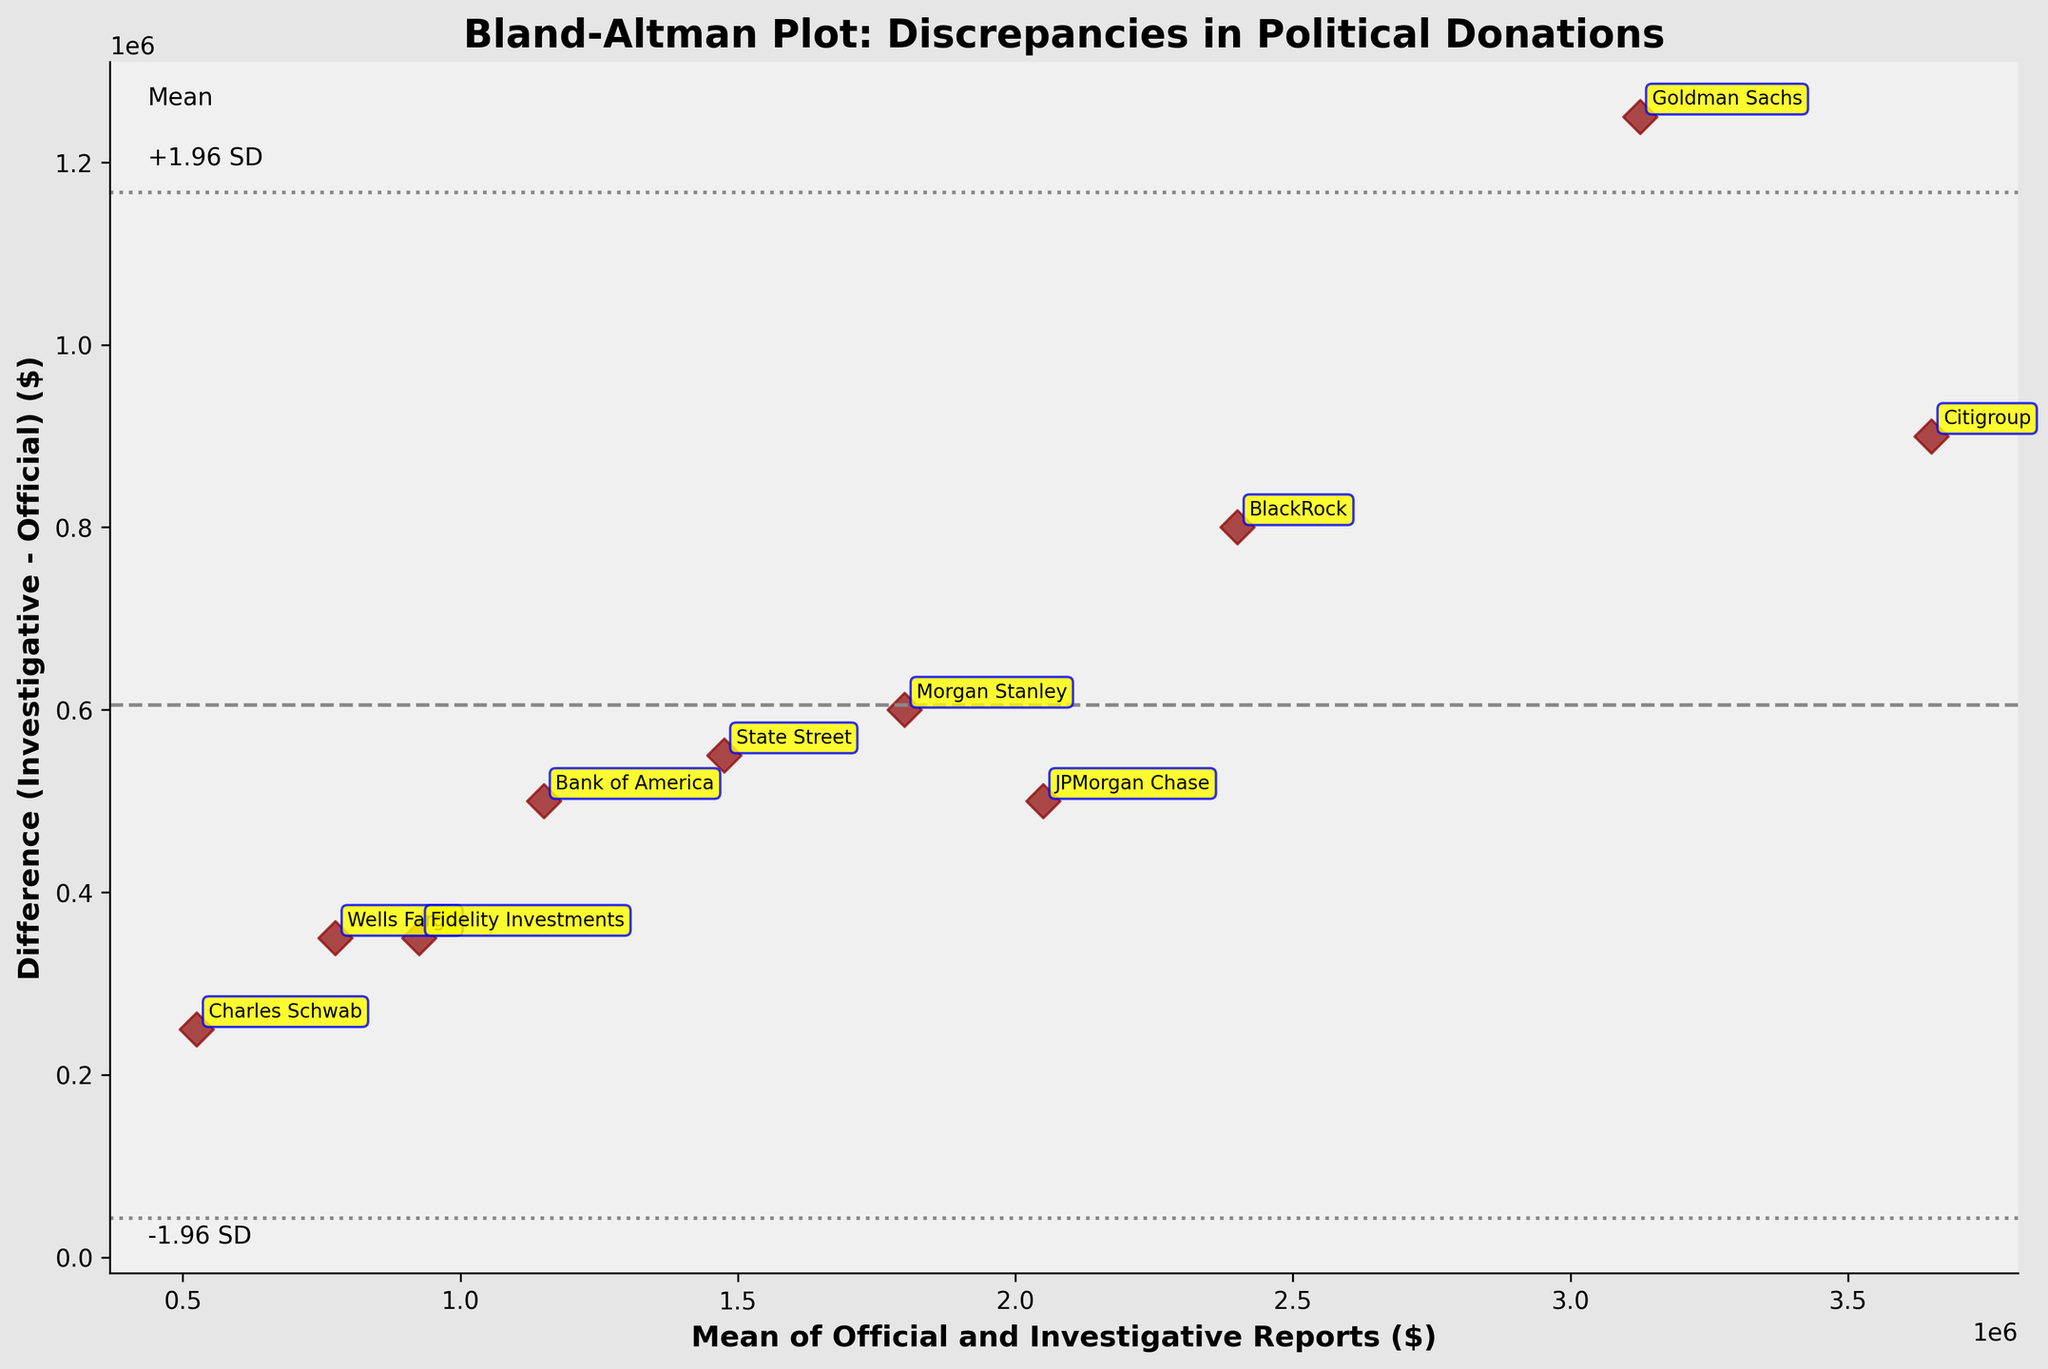What is the title of the plot? The plot's title is shown at the top of the figure and reads "Bland-Altman Plot: Discrepancies in Political Donations".
Answer: Bland-Altman Plot: Discrepancies in Political Donations Which firm shows the largest discrepancy between investigative and official reports? The largest discrepancy is indicated by the highest data point on the y-axis. Goldman Sachs has the highest difference (1,250,000).
Answer: Goldman Sachs What do the dashed horizontal lines represent? The dashed line at the center represents the mean difference, while the upper and lower dashed lines represent the mean difference ±1.96 times the standard deviation of the differences.
Answer: Mean difference, ±1.96 SD Which firm has the smallest (closest to zero) discrepancy between investigative and official reports? The firm with the smallest y-value (difference) is the one closest to zero. Charles Schwab shows the smallest difference (250,000).
Answer: Charles Schwab What is the color and shape used for the data points? The data points in the plot are represented as diamond-shaped ('D') markers and are colored dark red.
Answer: Dark red diamonds What is the mean of the documented and investigative donations for State Street? You can find State Street's mean on the x-axis where its corresponding label is situated. The mean value for State Street is (1,200,000 + 1,750,000) / 2 = 1,475,000.
Answer: 1,475,000 Which firm is represented by the data point with a mean donation value of 2,500,000? The firm with the mean donation value of 2,500,000 is located by finding the point on the x-axis closest to this value. JPMorgan Chase corresponds to this mean value ( (1,800,000 + 2,300,000) / 2 = 2,050,000 ).
Answer: JPMorgan Chase What is the average difference between investigative and official reports across all firms? Calculate the mean of the differences for all firms listed. Sum: 1250000 + 500000 + 900000 + 600000 + 500000 + 350000 + 800000 + 550000 + 350000 + 250000 = 6,550,000. Mean: 6,550,000 / 10 = 655,000.
Answer: 655,000 How many firms fall outside the limits of agreement (mean ±1.96 SD)? By visually inspecting the plot, observe data points that fall above or below the dashed lines. No firm exceeds the upper or lower limits on the plot.
Answer: None Which firm has a mean donation value closest to 3,150,000? Identify the point on the x-axis closest to 3,150,000 and check its label. Citigroup's mean value is (3,200,000 + 4,100,000) / 2 = 3,650,000, closest to 3,150,000.
Answer: Citigroup 